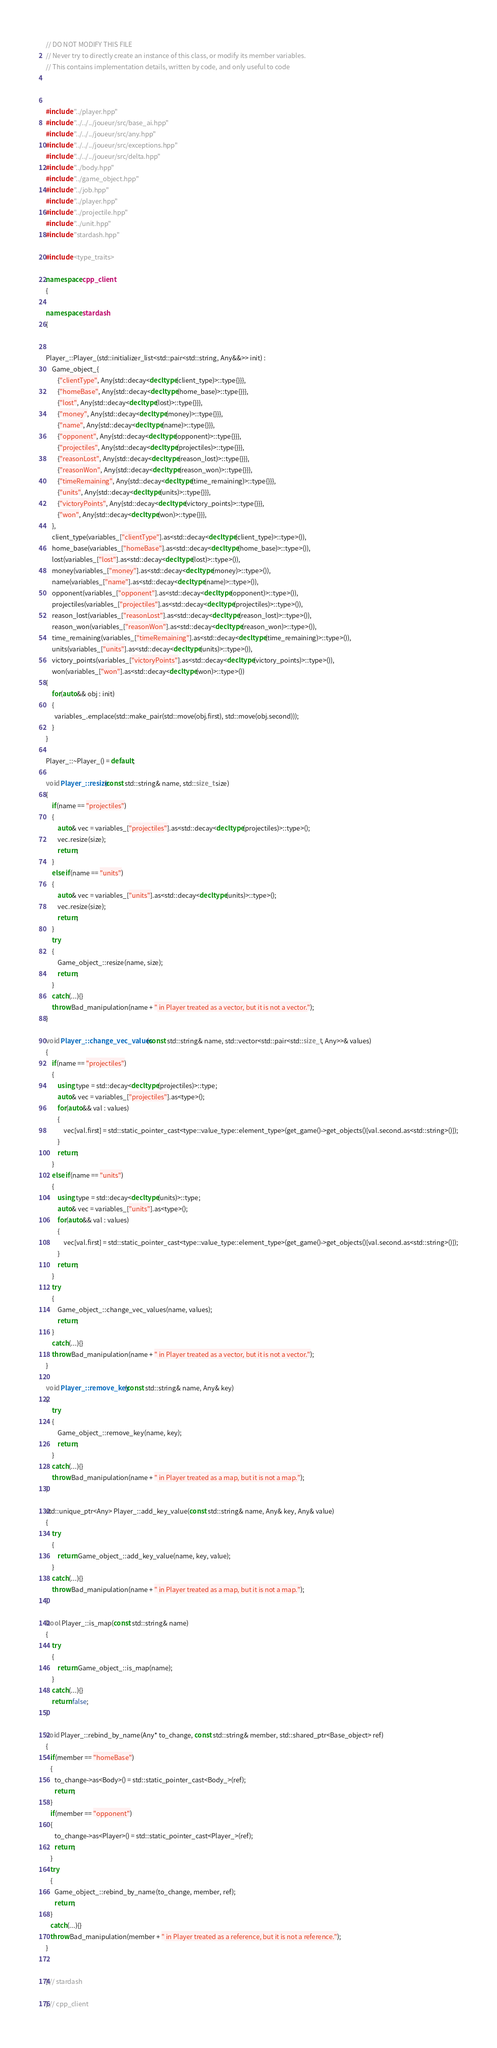<code> <loc_0><loc_0><loc_500><loc_500><_C++_>// DO NOT MODIFY THIS FILE
// Never try to directly create an instance of this class, or modify its member variables.
// This contains implementation details, written by code, and only useful to code



#include "../player.hpp"
#include "../../../joueur/src/base_ai.hpp"
#include "../../../joueur/src/any.hpp"
#include "../../../joueur/src/exceptions.hpp"
#include "../../../joueur/src/delta.hpp"
#include "../body.hpp"
#include "../game_object.hpp"
#include "../job.hpp"
#include "../player.hpp"
#include "../projectile.hpp"
#include "../unit.hpp"
#include "stardash.hpp"

#include <type_traits>

namespace cpp_client
{

namespace stardash
{


Player_::Player_(std::initializer_list<std::pair<std::string, Any&&>> init) :
    Game_object_{
        {"clientType", Any{std::decay<decltype(client_type)>::type{}}},
        {"homeBase", Any{std::decay<decltype(home_base)>::type{}}},
        {"lost", Any{std::decay<decltype(lost)>::type{}}},
        {"money", Any{std::decay<decltype(money)>::type{}}},
        {"name", Any{std::decay<decltype(name)>::type{}}},
        {"opponent", Any{std::decay<decltype(opponent)>::type{}}},
        {"projectiles", Any{std::decay<decltype(projectiles)>::type{}}},
        {"reasonLost", Any{std::decay<decltype(reason_lost)>::type{}}},
        {"reasonWon", Any{std::decay<decltype(reason_won)>::type{}}},
        {"timeRemaining", Any{std::decay<decltype(time_remaining)>::type{}}},
        {"units", Any{std::decay<decltype(units)>::type{}}},
        {"victoryPoints", Any{std::decay<decltype(victory_points)>::type{}}},
        {"won", Any{std::decay<decltype(won)>::type{}}},
    },
    client_type(variables_["clientType"].as<std::decay<decltype(client_type)>::type>()),
    home_base(variables_["homeBase"].as<std::decay<decltype(home_base)>::type>()),
    lost(variables_["lost"].as<std::decay<decltype(lost)>::type>()),
    money(variables_["money"].as<std::decay<decltype(money)>::type>()),
    name(variables_["name"].as<std::decay<decltype(name)>::type>()),
    opponent(variables_["opponent"].as<std::decay<decltype(opponent)>::type>()),
    projectiles(variables_["projectiles"].as<std::decay<decltype(projectiles)>::type>()),
    reason_lost(variables_["reasonLost"].as<std::decay<decltype(reason_lost)>::type>()),
    reason_won(variables_["reasonWon"].as<std::decay<decltype(reason_won)>::type>()),
    time_remaining(variables_["timeRemaining"].as<std::decay<decltype(time_remaining)>::type>()),
    units(variables_["units"].as<std::decay<decltype(units)>::type>()),
    victory_points(variables_["victoryPoints"].as<std::decay<decltype(victory_points)>::type>()),
    won(variables_["won"].as<std::decay<decltype(won)>::type>())
{
    for(auto&& obj : init)
    {
      variables_.emplace(std::make_pair(std::move(obj.first), std::move(obj.second)));
    }
}

Player_::~Player_() = default;

void Player_::resize(const std::string& name, std::size_t size)
{
    if(name == "projectiles")
    {
        auto& vec = variables_["projectiles"].as<std::decay<decltype(projectiles)>::type>();
        vec.resize(size);
        return;
    }
    else if(name == "units")
    {
        auto& vec = variables_["units"].as<std::decay<decltype(units)>::type>();
        vec.resize(size);
        return;
    }
    try
    {
        Game_object_::resize(name, size);
        return;
    }
    catch(...){}
    throw Bad_manipulation(name + " in Player treated as a vector, but it is not a vector.");
}

void Player_::change_vec_values(const std::string& name, std::vector<std::pair<std::size_t, Any>>& values)
{
    if(name == "projectiles")
    {
        using type = std::decay<decltype(projectiles)>::type;
        auto& vec = variables_["projectiles"].as<type>();
        for(auto&& val : values)
        { 
            vec[val.first] = std::static_pointer_cast<type::value_type::element_type>(get_game()->get_objects()[val.second.as<std::string>()]);
        }
        return;
    } 
    else if(name == "units")
    {
        using type = std::decay<decltype(units)>::type;
        auto& vec = variables_["units"].as<type>();
        for(auto&& val : values)
        { 
            vec[val.first] = std::static_pointer_cast<type::value_type::element_type>(get_game()->get_objects()[val.second.as<std::string>()]);
        }
        return;
    } 
    try
    {
        Game_object_::change_vec_values(name, values);
        return;
    }
    catch(...){}
    throw Bad_manipulation(name + " in Player treated as a vector, but it is not a vector.");
}

void Player_::remove_key(const std::string& name, Any& key)
{
    try
    {
        Game_object_::remove_key(name, key);
        return;
    }
    catch(...){}
    throw Bad_manipulation(name + " in Player treated as a map, but it is not a map.");
}

std::unique_ptr<Any> Player_::add_key_value(const std::string& name, Any& key, Any& value)
{
    try
    {
        return Game_object_::add_key_value(name, key, value);
    }
    catch(...){}
    throw Bad_manipulation(name + " in Player treated as a map, but it is not a map.");
}

bool Player_::is_map(const std::string& name)
{
    try
    {
        return Game_object_::is_map(name);
    }
    catch(...){}
    return false;
}

void Player_::rebind_by_name(Any* to_change, const std::string& member, std::shared_ptr<Base_object> ref)
{
   if(member == "homeBase")
   { 
      to_change->as<Body>() = std::static_pointer_cast<Body_>(ref);
      return;
   }
   if(member == "opponent")
   { 
      to_change->as<Player>() = std::static_pointer_cast<Player_>(ref);
      return;
   }
   try
   {
      Game_object_::rebind_by_name(to_change, member, ref);
      return;
   }
   catch(...){}
   throw Bad_manipulation(member + " in Player treated as a reference, but it is not a reference.");
}


} // stardash

} // cpp_client
</code> 